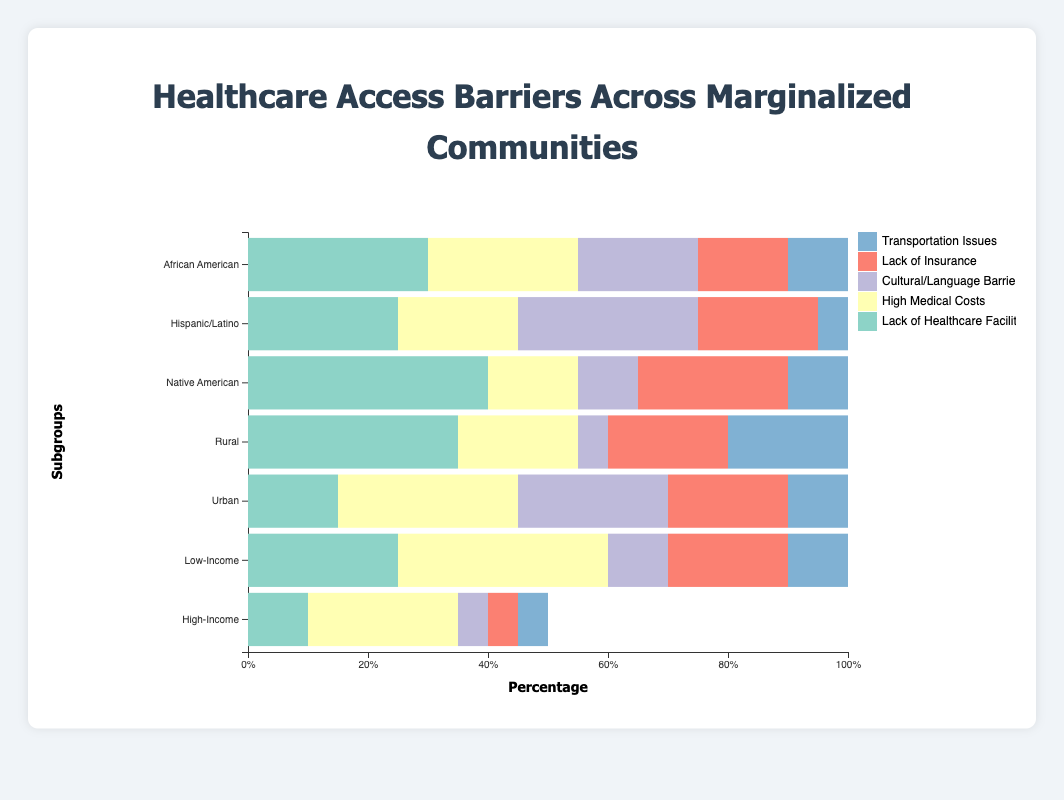Which subgroup within 'Racial/Ethnic Minority Groups' has the highest percentage for 'Lack of Healthcare Facilities'? Check the bars for 'Lack of Healthcare Facilities' within 'Racial/Ethnic Minority Groups'. The Native American subgroup has the highest percentage (40%).
Answer: Native American Which subgroup has the highest percentage for 'High Medical Costs'? Compare all the bars representing 'High Medical Costs'. The Low-Income subgroup within the 'Income' group has the highest percentage (35%).
Answer: Low-Income What is the total percentage for 'Lack of Insurance' and 'Transportation Issues' in the Rural subgroup? Add the percentages for 'Lack of Insurance' (20%) and 'Transportation Issues' (20%) for the Rural subgroup. 20 + 20 = 40
Answer: 40 What are the three most significant barriers faced by the Hispanic/Latino subgroup? Identify the top three highest percentages within the Hispanic/Latino subgroup. They are Cultural/Language Barriers (30%), Lack of Insurance (20%), and Lack of Healthcare Facilities (25%)
Answer: Cultural/Language Barriers, Lack of Insurance, Lack of Healthcare Facilities Compare 'Lack of Healthcare Facilities' between Rural and Urban subgroups. Which one is higher and by how much? Check the percentages for 'Lack of Healthcare Facilities' in Rural (35%) and Urban (15%). 35 - 15 = 20
Answer: Rural by 20 What is the most common barrier across all subgroups? Identify the barriers with the highest percentages across all subgroups. 'Lack of Healthcare Facilities' appears frequently and 40% in Native American is the highest.
Answer: Lack of Healthcare Facilities Which subgroup within 'Income' has a higher percentage for 'Cultural/Language Barriers', and by how much? Compare the percentages for 'Cultural/Language Barriers' within Low-Income (10%) and High-Income (5%) subgroups. 10 - 5 = 5
Answer: Low-Income by 5 What is the combined percentage of 'Lack of Healthcare Facilities' and 'High Medical Costs' for the African American subgroup? Add percentages for 'Lack of Healthcare Facilities' (30%) and 'High Medical Costs' (25%). 30 + 25 = 55
Answer: 55 Which barrier is least significant for the High-Income subgroup? The barrier with the smallest percentage within the High-Income subgroup is 'Transportation Issues' (5%).
Answer: Transportation Issues 